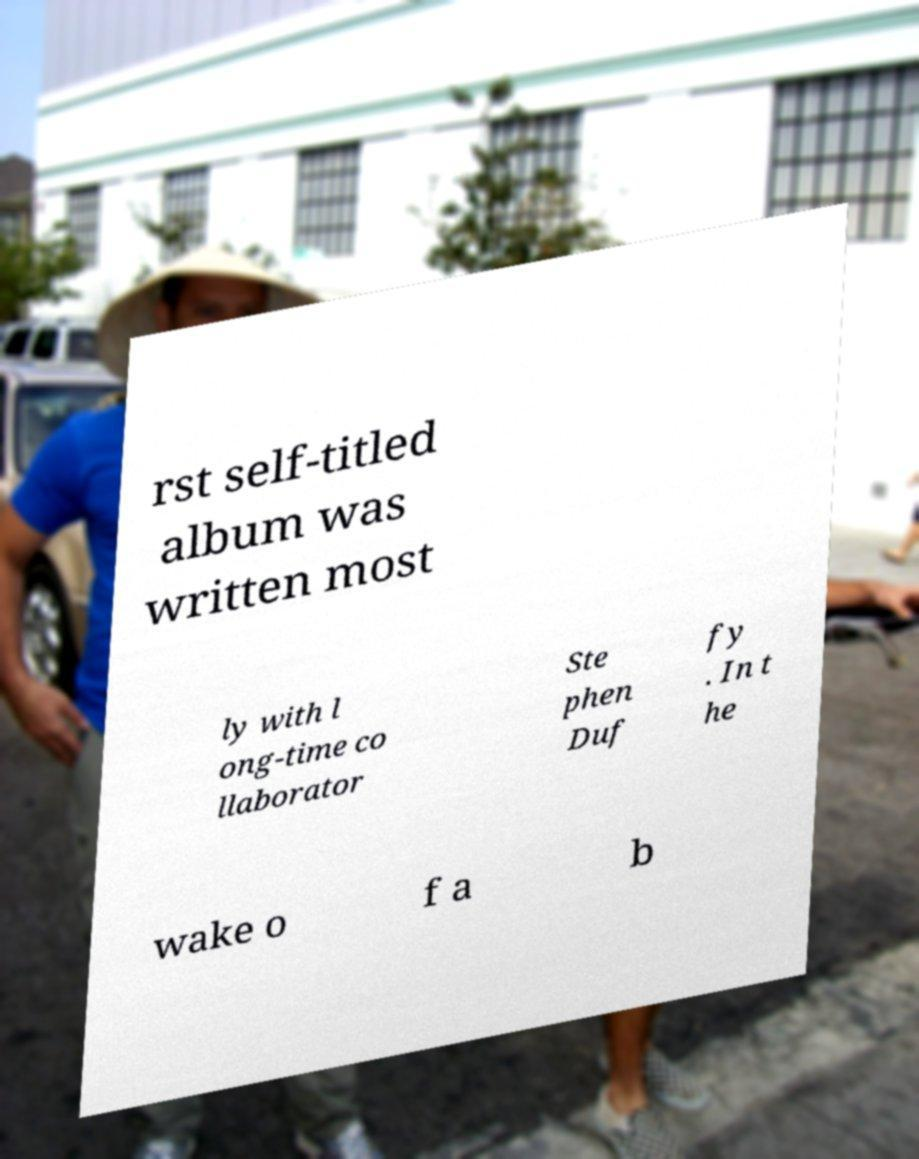Please identify and transcribe the text found in this image. rst self-titled album was written most ly with l ong-time co llaborator Ste phen Duf fy . In t he wake o f a b 